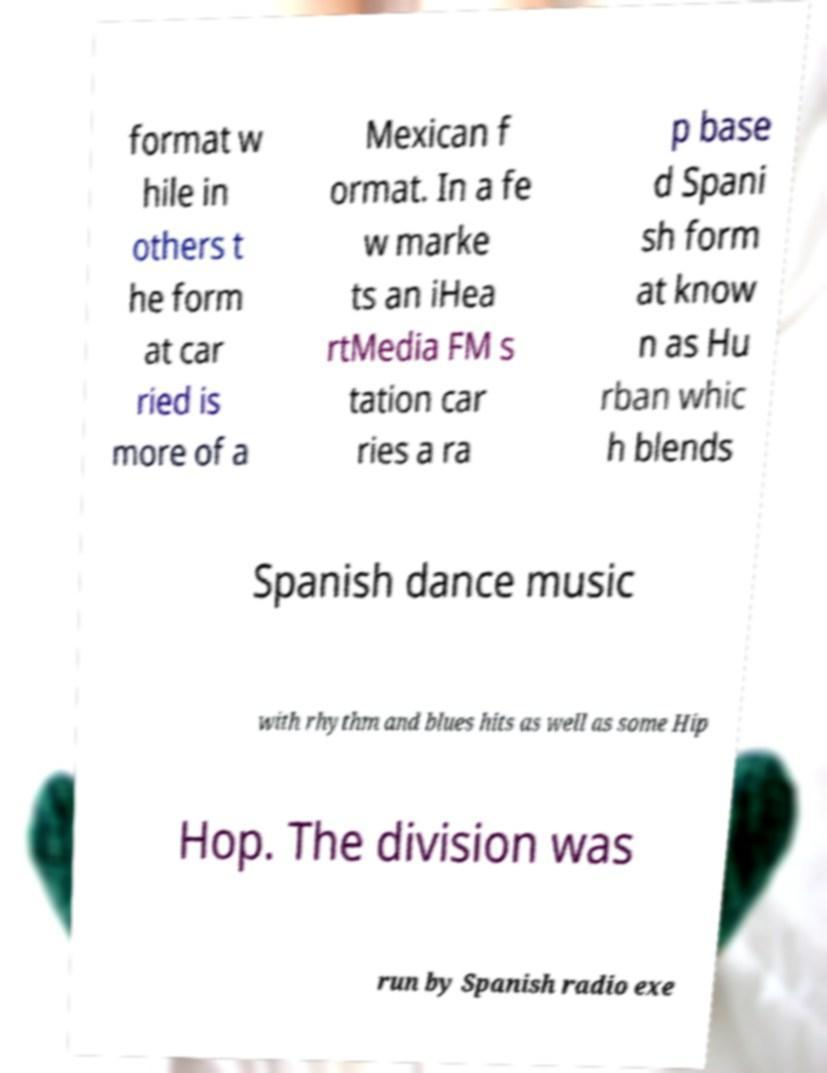For documentation purposes, I need the text within this image transcribed. Could you provide that? format w hile in others t he form at car ried is more of a Mexican f ormat. In a fe w marke ts an iHea rtMedia FM s tation car ries a ra p base d Spani sh form at know n as Hu rban whic h blends Spanish dance music with rhythm and blues hits as well as some Hip Hop. The division was run by Spanish radio exe 